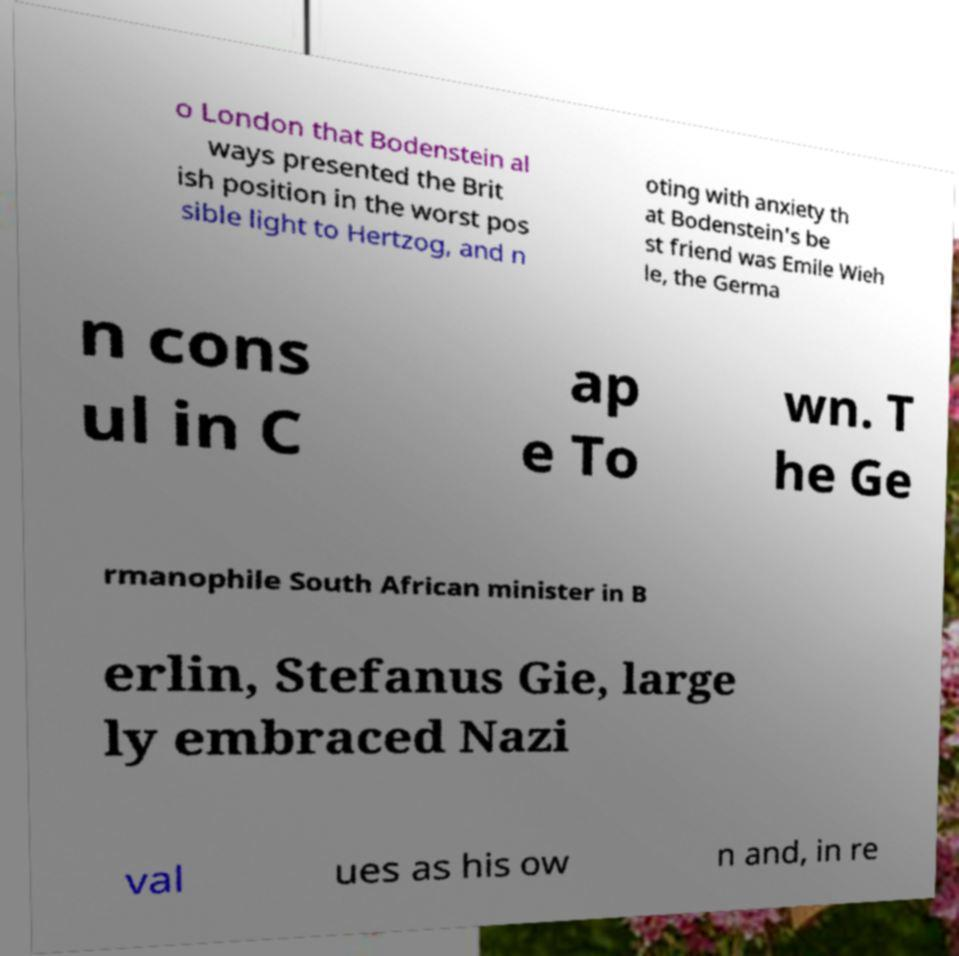Can you read and provide the text displayed in the image?This photo seems to have some interesting text. Can you extract and type it out for me? o London that Bodenstein al ways presented the Brit ish position in the worst pos sible light to Hertzog, and n oting with anxiety th at Bodenstein's be st friend was Emile Wieh le, the Germa n cons ul in C ap e To wn. T he Ge rmanophile South African minister in B erlin, Stefanus Gie, large ly embraced Nazi val ues as his ow n and, in re 